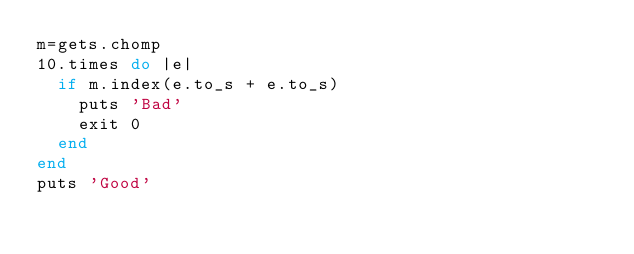<code> <loc_0><loc_0><loc_500><loc_500><_Ruby_>m=gets.chomp
10.times do |e|
  if m.index(e.to_s + e.to_s)
    puts 'Bad'
    exit 0
  end
end
puts 'Good'
</code> 